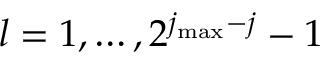Convert formula to latex. <formula><loc_0><loc_0><loc_500><loc_500>l = 1 , \dots , 2 ^ { j _ { \max } - j } - 1</formula> 